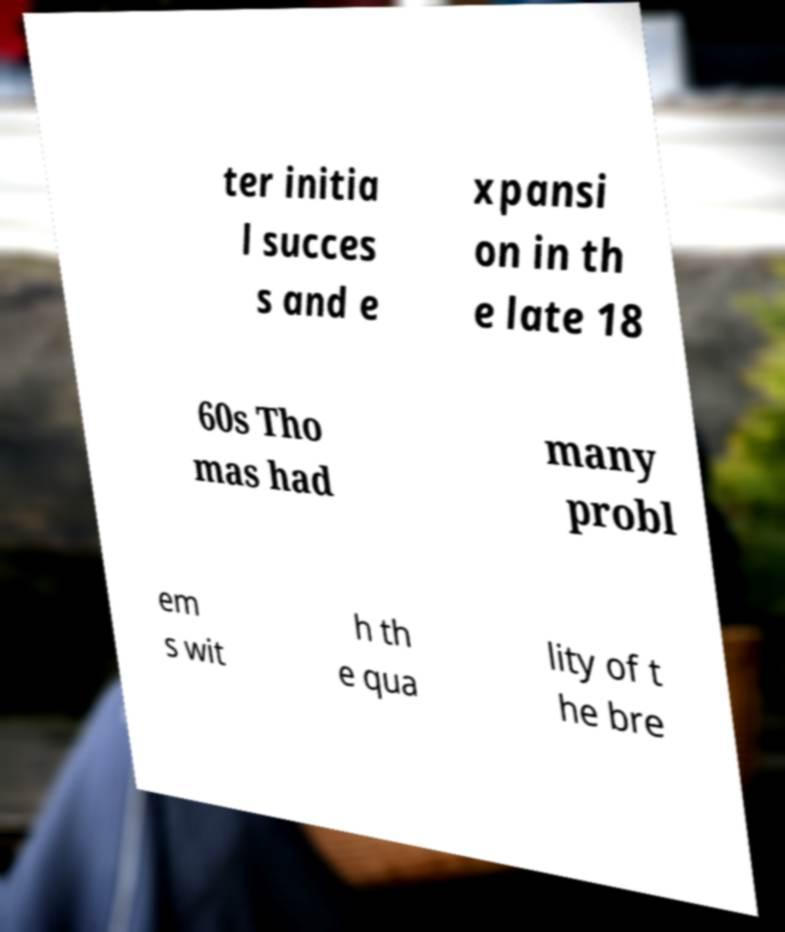Could you extract and type out the text from this image? ter initia l succes s and e xpansi on in th e late 18 60s Tho mas had many probl em s wit h th e qua lity of t he bre 